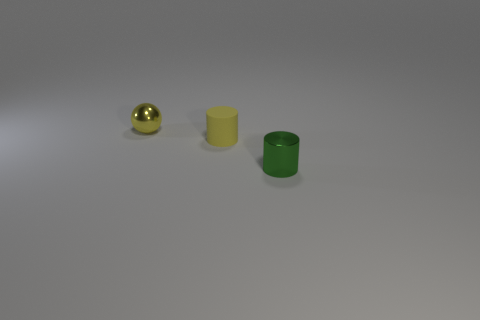Are there any other things that have the same material as the small yellow cylinder?
Your answer should be very brief. No. What shape is the shiny object that is the same color as the rubber cylinder?
Offer a terse response. Sphere. The ball has what size?
Provide a succinct answer. Small. Is the size of the yellow sphere the same as the cylinder behind the metallic cylinder?
Give a very brief answer. Yes. What number of yellow things are tiny matte cylinders or small metallic blocks?
Keep it short and to the point. 1. What number of tiny gray metal cylinders are there?
Offer a terse response. 0. There is a shiny thing behind the tiny green thing; what is its size?
Keep it short and to the point. Small. Do the green shiny thing and the rubber cylinder have the same size?
Offer a very short reply. Yes. What number of objects are either small yellow metal balls or metallic things behind the tiny green metal cylinder?
Provide a short and direct response. 1. What material is the tiny green object?
Your answer should be very brief. Metal. 